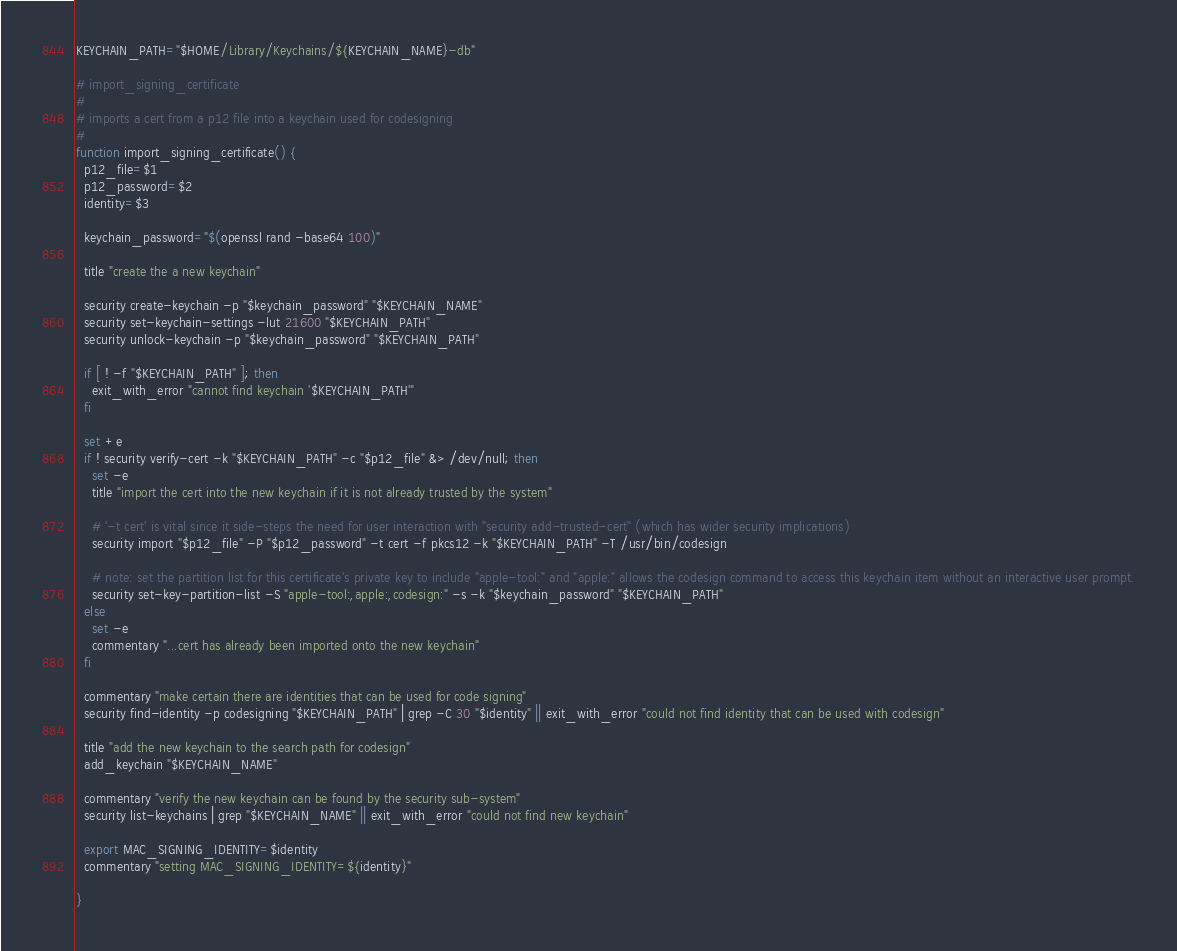Convert code to text. <code><loc_0><loc_0><loc_500><loc_500><_Bash_>KEYCHAIN_PATH="$HOME/Library/Keychains/${KEYCHAIN_NAME}-db"

# import_signing_certificate
#
# imports a cert from a p12 file into a keychain used for codesigning
#
function import_signing_certificate() {
  p12_file=$1
  p12_password=$2
  identity=$3

  keychain_password="$(openssl rand -base64 100)"

  title "create the a new keychain"

  security create-keychain -p "$keychain_password" "$KEYCHAIN_NAME"
  security set-keychain-settings -lut 21600 "$KEYCHAIN_PATH"
  security unlock-keychain -p "$keychain_password" "$KEYCHAIN_PATH"

  if [ ! -f "$KEYCHAIN_PATH" ]; then
    exit_with_error "cannot find keychain '$KEYCHAIN_PATH'"
  fi

  set +e
  if ! security verify-cert -k "$KEYCHAIN_PATH" -c "$p12_file" &> /dev/null; then
    set -e
    title "import the cert into the new keychain if it is not already trusted by the system"

    # '-t cert' is vital since it side-steps the need for user interaction with "security add-trusted-cert" (which has wider security implications)
    security import "$p12_file" -P "$p12_password" -t cert -f pkcs12 -k "$KEYCHAIN_PATH" -T /usr/bin/codesign

    # note: set the partition list for this certificate's private key to include "apple-tool:" and "apple:" allows the codesign command to access this keychain item without an interactive user prompt.
    security set-key-partition-list -S "apple-tool:,apple:,codesign:" -s -k "$keychain_password" "$KEYCHAIN_PATH"
  else
    set -e
    commentary "...cert has already been imported onto the new keychain"
  fi

  commentary "make certain there are identities that can be used for code signing"
  security find-identity -p codesigning "$KEYCHAIN_PATH" | grep -C 30 "$identity" || exit_with_error "could not find identity that can be used with codesign"

  title "add the new keychain to the search path for codesign"
  add_keychain "$KEYCHAIN_NAME"

  commentary "verify the new keychain can be found by the security sub-system"
  security list-keychains | grep "$KEYCHAIN_NAME" || exit_with_error "could not find new keychain"

  export MAC_SIGNING_IDENTITY=$identity
  commentary "setting MAC_SIGNING_IDENTITY=${identity}"

}
</code> 